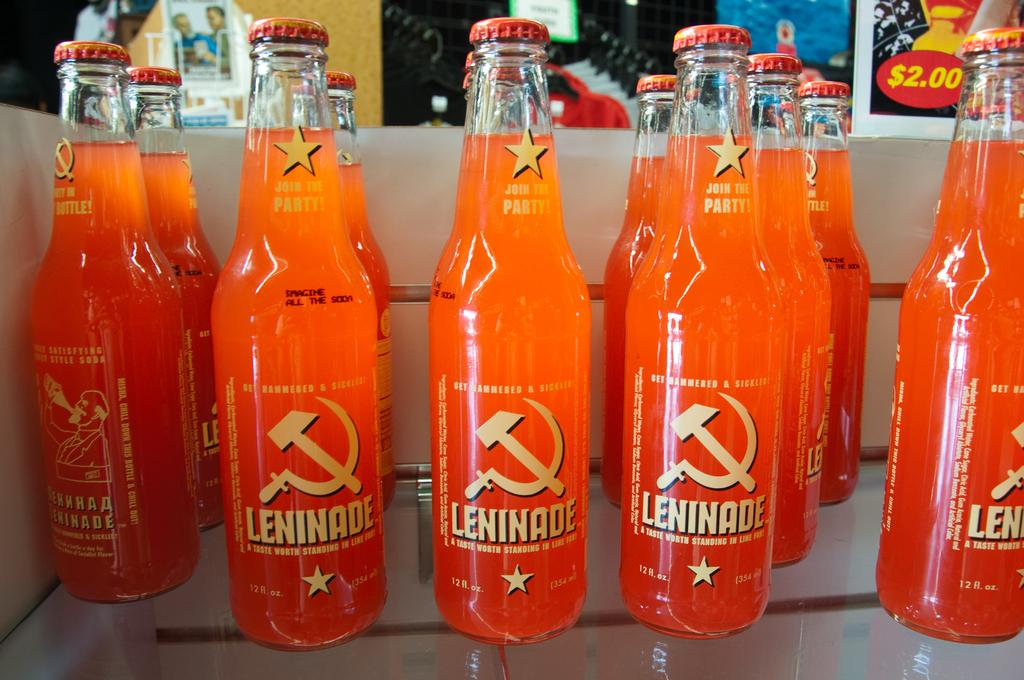<image>
Summarize the visual content of the image. eleven 12 ounce bottles of orange leninade drink 